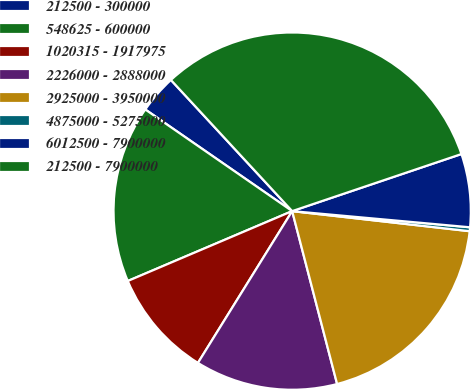Convert chart to OTSL. <chart><loc_0><loc_0><loc_500><loc_500><pie_chart><fcel>212500 - 300000<fcel>548625 - 600000<fcel>1020315 - 1917975<fcel>2226000 - 2888000<fcel>2925000 - 3950000<fcel>4875000 - 5275000<fcel>6012500 - 7900000<fcel>212500 - 7900000<nl><fcel>3.49%<fcel>16.03%<fcel>9.76%<fcel>12.89%<fcel>19.16%<fcel>0.35%<fcel>6.62%<fcel>31.7%<nl></chart> 